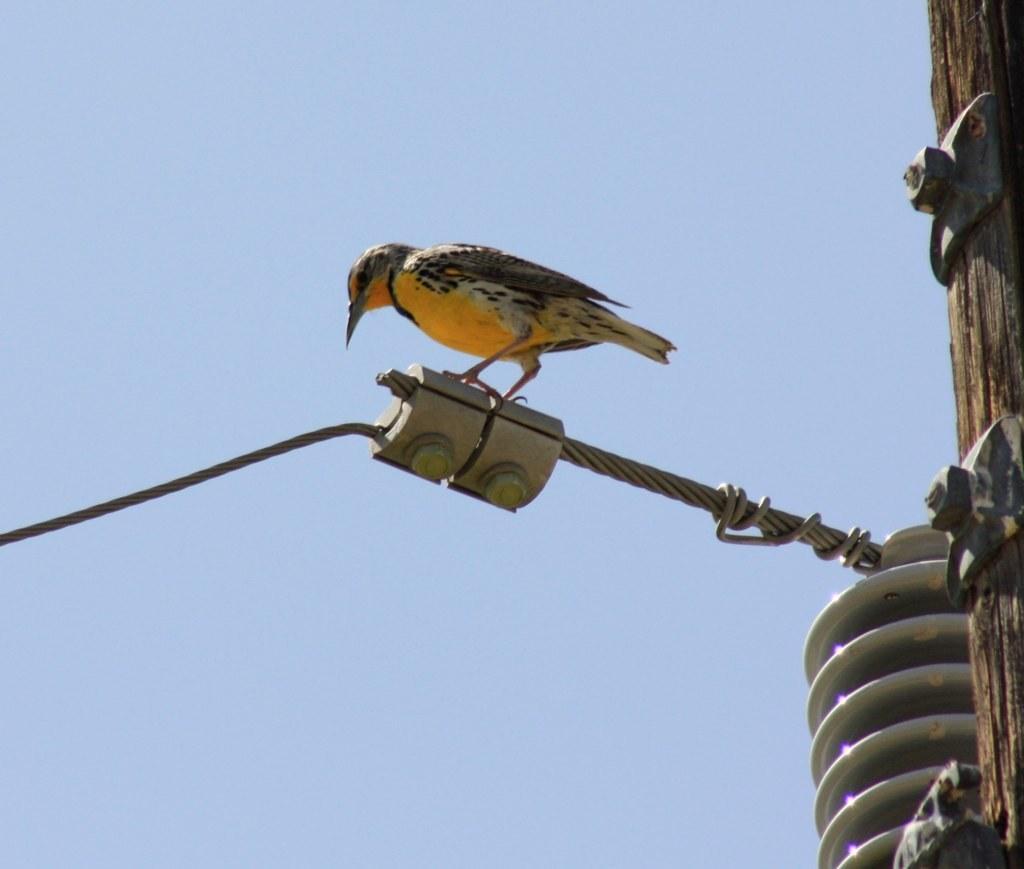Describe this image in one or two sentences. In this image I can see a bird which is in brown and white color standing on the pole, at back sky is in blue color. 